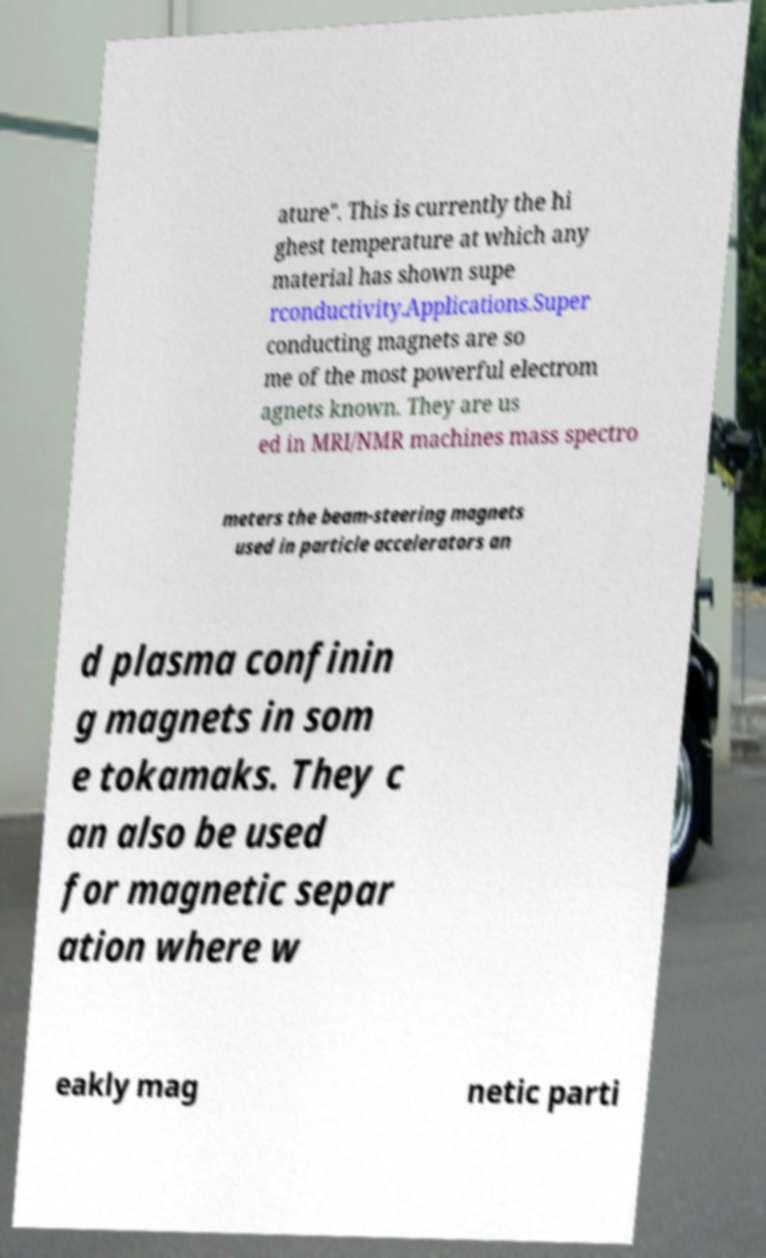Please identify and transcribe the text found in this image. ature". This is currently the hi ghest temperature at which any material has shown supe rconductivity.Applications.Super conducting magnets are so me of the most powerful electrom agnets known. They are us ed in MRI/NMR machines mass spectro meters the beam-steering magnets used in particle accelerators an d plasma confinin g magnets in som e tokamaks. They c an also be used for magnetic separ ation where w eakly mag netic parti 